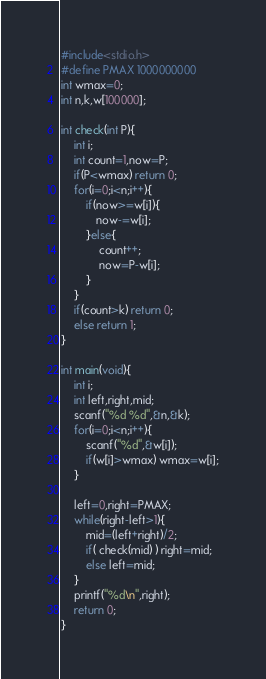Convert code to text. <code><loc_0><loc_0><loc_500><loc_500><_C_>#include<stdio.h>
#define PMAX 1000000000
int wmax=0;
int n,k,w[100000];
 
int check(int P){
    int i;
    int count=1,now=P;
    if(P<wmax) return 0;
    for(i=0;i<n;i++){
        if(now>=w[i]){
           now-=w[i];
        }else{
            count++;
            now=P-w[i];
        }
    }
    if(count>k) return 0;
    else return 1;
}
 
int main(void){
    int i;
    int left,right,mid;
    scanf("%d %d",&n,&k);
    for(i=0;i<n;i++){
        scanf("%d",&w[i]);
        if(w[i]>wmax) wmax=w[i];
    }
 
    left=0,right=PMAX;
    while(right-left>1){
        mid=(left+right)/2;
        if( check(mid) ) right=mid;
        else left=mid;
    }
    printf("%d\n",right);
    return 0;
}
</code> 